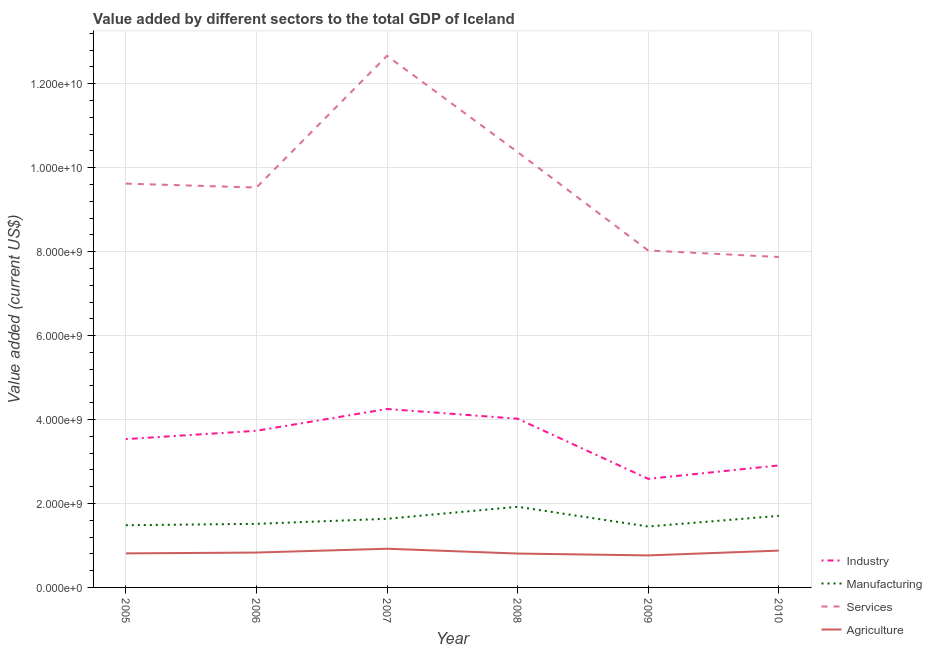How many different coloured lines are there?
Your response must be concise. 4. Is the number of lines equal to the number of legend labels?
Offer a terse response. Yes. What is the value added by manufacturing sector in 2008?
Offer a terse response. 1.92e+09. Across all years, what is the maximum value added by services sector?
Your answer should be compact. 1.27e+1. Across all years, what is the minimum value added by services sector?
Provide a short and direct response. 7.87e+09. What is the total value added by industrial sector in the graph?
Give a very brief answer. 2.10e+1. What is the difference between the value added by industrial sector in 2005 and that in 2006?
Make the answer very short. -1.99e+08. What is the difference between the value added by industrial sector in 2006 and the value added by agricultural sector in 2010?
Provide a succinct answer. 2.85e+09. What is the average value added by agricultural sector per year?
Keep it short and to the point. 8.35e+08. In the year 2006, what is the difference between the value added by manufacturing sector and value added by agricultural sector?
Your answer should be very brief. 6.84e+08. In how many years, is the value added by agricultural sector greater than 11200000000 US$?
Your answer should be compact. 0. What is the ratio of the value added by services sector in 2008 to that in 2010?
Your answer should be compact. 1.32. What is the difference between the highest and the second highest value added by agricultural sector?
Keep it short and to the point. 4.46e+07. What is the difference between the highest and the lowest value added by manufacturing sector?
Your answer should be very brief. 4.70e+08. Does the value added by services sector monotonically increase over the years?
Offer a terse response. No. Is the value added by manufacturing sector strictly less than the value added by industrial sector over the years?
Offer a terse response. Yes. How many lines are there?
Ensure brevity in your answer.  4. How many years are there in the graph?
Ensure brevity in your answer.  6. What is the difference between two consecutive major ticks on the Y-axis?
Provide a short and direct response. 2.00e+09. How many legend labels are there?
Offer a terse response. 4. What is the title of the graph?
Provide a succinct answer. Value added by different sectors to the total GDP of Iceland. What is the label or title of the X-axis?
Provide a short and direct response. Year. What is the label or title of the Y-axis?
Your answer should be compact. Value added (current US$). What is the Value added (current US$) in Industry in 2005?
Provide a short and direct response. 3.53e+09. What is the Value added (current US$) of Manufacturing in 2005?
Your answer should be very brief. 1.48e+09. What is the Value added (current US$) in Services in 2005?
Your response must be concise. 9.62e+09. What is the Value added (current US$) of Agriculture in 2005?
Your answer should be compact. 8.11e+08. What is the Value added (current US$) of Industry in 2006?
Provide a short and direct response. 3.73e+09. What is the Value added (current US$) in Manufacturing in 2006?
Offer a terse response. 1.51e+09. What is the Value added (current US$) in Services in 2006?
Keep it short and to the point. 9.53e+09. What is the Value added (current US$) in Agriculture in 2006?
Your answer should be compact. 8.31e+08. What is the Value added (current US$) in Industry in 2007?
Ensure brevity in your answer.  4.25e+09. What is the Value added (current US$) of Manufacturing in 2007?
Make the answer very short. 1.64e+09. What is the Value added (current US$) in Services in 2007?
Keep it short and to the point. 1.27e+1. What is the Value added (current US$) of Agriculture in 2007?
Give a very brief answer. 9.22e+08. What is the Value added (current US$) in Industry in 2008?
Give a very brief answer. 4.02e+09. What is the Value added (current US$) in Manufacturing in 2008?
Offer a very short reply. 1.92e+09. What is the Value added (current US$) of Services in 2008?
Give a very brief answer. 1.04e+1. What is the Value added (current US$) of Agriculture in 2008?
Offer a very short reply. 8.07e+08. What is the Value added (current US$) of Industry in 2009?
Your answer should be compact. 2.59e+09. What is the Value added (current US$) in Manufacturing in 2009?
Provide a succinct answer. 1.45e+09. What is the Value added (current US$) in Services in 2009?
Ensure brevity in your answer.  8.03e+09. What is the Value added (current US$) of Agriculture in 2009?
Your answer should be compact. 7.63e+08. What is the Value added (current US$) in Industry in 2010?
Your answer should be compact. 2.91e+09. What is the Value added (current US$) in Manufacturing in 2010?
Provide a succinct answer. 1.71e+09. What is the Value added (current US$) in Services in 2010?
Provide a succinct answer. 7.87e+09. What is the Value added (current US$) of Agriculture in 2010?
Give a very brief answer. 8.77e+08. Across all years, what is the maximum Value added (current US$) in Industry?
Provide a short and direct response. 4.25e+09. Across all years, what is the maximum Value added (current US$) of Manufacturing?
Give a very brief answer. 1.92e+09. Across all years, what is the maximum Value added (current US$) of Services?
Make the answer very short. 1.27e+1. Across all years, what is the maximum Value added (current US$) in Agriculture?
Your answer should be very brief. 9.22e+08. Across all years, what is the minimum Value added (current US$) of Industry?
Provide a short and direct response. 2.59e+09. Across all years, what is the minimum Value added (current US$) of Manufacturing?
Your answer should be very brief. 1.45e+09. Across all years, what is the minimum Value added (current US$) of Services?
Provide a succinct answer. 7.87e+09. Across all years, what is the minimum Value added (current US$) in Agriculture?
Ensure brevity in your answer.  7.63e+08. What is the total Value added (current US$) in Industry in the graph?
Give a very brief answer. 2.10e+1. What is the total Value added (current US$) of Manufacturing in the graph?
Offer a very short reply. 9.71e+09. What is the total Value added (current US$) of Services in the graph?
Give a very brief answer. 5.81e+1. What is the total Value added (current US$) of Agriculture in the graph?
Offer a terse response. 5.01e+09. What is the difference between the Value added (current US$) in Industry in 2005 and that in 2006?
Your answer should be compact. -1.99e+08. What is the difference between the Value added (current US$) of Manufacturing in 2005 and that in 2006?
Offer a terse response. -3.30e+07. What is the difference between the Value added (current US$) in Services in 2005 and that in 2006?
Provide a succinct answer. 9.41e+07. What is the difference between the Value added (current US$) of Agriculture in 2005 and that in 2006?
Your response must be concise. -1.96e+07. What is the difference between the Value added (current US$) in Industry in 2005 and that in 2007?
Your answer should be very brief. -7.18e+08. What is the difference between the Value added (current US$) in Manufacturing in 2005 and that in 2007?
Offer a terse response. -1.54e+08. What is the difference between the Value added (current US$) in Services in 2005 and that in 2007?
Your answer should be compact. -3.04e+09. What is the difference between the Value added (current US$) in Agriculture in 2005 and that in 2007?
Offer a terse response. -1.11e+08. What is the difference between the Value added (current US$) in Industry in 2005 and that in 2008?
Provide a succinct answer. -4.86e+08. What is the difference between the Value added (current US$) in Manufacturing in 2005 and that in 2008?
Offer a very short reply. -4.40e+08. What is the difference between the Value added (current US$) of Services in 2005 and that in 2008?
Offer a very short reply. -7.51e+08. What is the difference between the Value added (current US$) of Agriculture in 2005 and that in 2008?
Provide a succinct answer. 4.00e+06. What is the difference between the Value added (current US$) of Industry in 2005 and that in 2009?
Provide a succinct answer. 9.47e+08. What is the difference between the Value added (current US$) of Manufacturing in 2005 and that in 2009?
Your answer should be compact. 3.03e+07. What is the difference between the Value added (current US$) in Services in 2005 and that in 2009?
Offer a terse response. 1.59e+09. What is the difference between the Value added (current US$) of Agriculture in 2005 and that in 2009?
Keep it short and to the point. 4.81e+07. What is the difference between the Value added (current US$) in Industry in 2005 and that in 2010?
Provide a succinct answer. 6.27e+08. What is the difference between the Value added (current US$) of Manufacturing in 2005 and that in 2010?
Offer a terse response. -2.24e+08. What is the difference between the Value added (current US$) in Services in 2005 and that in 2010?
Offer a terse response. 1.75e+09. What is the difference between the Value added (current US$) of Agriculture in 2005 and that in 2010?
Make the answer very short. -6.60e+07. What is the difference between the Value added (current US$) of Industry in 2006 and that in 2007?
Provide a short and direct response. -5.20e+08. What is the difference between the Value added (current US$) of Manufacturing in 2006 and that in 2007?
Your answer should be very brief. -1.21e+08. What is the difference between the Value added (current US$) in Services in 2006 and that in 2007?
Your response must be concise. -3.14e+09. What is the difference between the Value added (current US$) of Agriculture in 2006 and that in 2007?
Offer a very short reply. -9.09e+07. What is the difference between the Value added (current US$) in Industry in 2006 and that in 2008?
Make the answer very short. -2.88e+08. What is the difference between the Value added (current US$) of Manufacturing in 2006 and that in 2008?
Ensure brevity in your answer.  -4.07e+08. What is the difference between the Value added (current US$) in Services in 2006 and that in 2008?
Your answer should be very brief. -8.45e+08. What is the difference between the Value added (current US$) of Agriculture in 2006 and that in 2008?
Ensure brevity in your answer.  2.36e+07. What is the difference between the Value added (current US$) in Industry in 2006 and that in 2009?
Keep it short and to the point. 1.15e+09. What is the difference between the Value added (current US$) of Manufacturing in 2006 and that in 2009?
Give a very brief answer. 6.34e+07. What is the difference between the Value added (current US$) of Services in 2006 and that in 2009?
Your answer should be compact. 1.50e+09. What is the difference between the Value added (current US$) in Agriculture in 2006 and that in 2009?
Provide a succinct answer. 6.78e+07. What is the difference between the Value added (current US$) in Industry in 2006 and that in 2010?
Your response must be concise. 8.25e+08. What is the difference between the Value added (current US$) in Manufacturing in 2006 and that in 2010?
Offer a very short reply. -1.91e+08. What is the difference between the Value added (current US$) of Services in 2006 and that in 2010?
Your response must be concise. 1.65e+09. What is the difference between the Value added (current US$) of Agriculture in 2006 and that in 2010?
Make the answer very short. -4.64e+07. What is the difference between the Value added (current US$) of Industry in 2007 and that in 2008?
Make the answer very short. 2.32e+08. What is the difference between the Value added (current US$) of Manufacturing in 2007 and that in 2008?
Provide a short and direct response. -2.86e+08. What is the difference between the Value added (current US$) in Services in 2007 and that in 2008?
Provide a succinct answer. 2.29e+09. What is the difference between the Value added (current US$) of Agriculture in 2007 and that in 2008?
Provide a short and direct response. 1.15e+08. What is the difference between the Value added (current US$) in Industry in 2007 and that in 2009?
Your response must be concise. 1.66e+09. What is the difference between the Value added (current US$) of Manufacturing in 2007 and that in 2009?
Offer a terse response. 1.84e+08. What is the difference between the Value added (current US$) of Services in 2007 and that in 2009?
Ensure brevity in your answer.  4.64e+09. What is the difference between the Value added (current US$) in Agriculture in 2007 and that in 2009?
Keep it short and to the point. 1.59e+08. What is the difference between the Value added (current US$) in Industry in 2007 and that in 2010?
Ensure brevity in your answer.  1.35e+09. What is the difference between the Value added (current US$) of Manufacturing in 2007 and that in 2010?
Your answer should be compact. -7.01e+07. What is the difference between the Value added (current US$) in Services in 2007 and that in 2010?
Your answer should be compact. 4.79e+09. What is the difference between the Value added (current US$) of Agriculture in 2007 and that in 2010?
Ensure brevity in your answer.  4.46e+07. What is the difference between the Value added (current US$) of Industry in 2008 and that in 2009?
Ensure brevity in your answer.  1.43e+09. What is the difference between the Value added (current US$) in Manufacturing in 2008 and that in 2009?
Keep it short and to the point. 4.70e+08. What is the difference between the Value added (current US$) in Services in 2008 and that in 2009?
Give a very brief answer. 2.34e+09. What is the difference between the Value added (current US$) in Agriculture in 2008 and that in 2009?
Provide a short and direct response. 4.41e+07. What is the difference between the Value added (current US$) of Industry in 2008 and that in 2010?
Ensure brevity in your answer.  1.11e+09. What is the difference between the Value added (current US$) of Manufacturing in 2008 and that in 2010?
Provide a succinct answer. 2.16e+08. What is the difference between the Value added (current US$) of Services in 2008 and that in 2010?
Give a very brief answer. 2.50e+09. What is the difference between the Value added (current US$) in Agriculture in 2008 and that in 2010?
Offer a terse response. -7.00e+07. What is the difference between the Value added (current US$) in Industry in 2009 and that in 2010?
Provide a short and direct response. -3.20e+08. What is the difference between the Value added (current US$) in Manufacturing in 2009 and that in 2010?
Provide a short and direct response. -2.54e+08. What is the difference between the Value added (current US$) in Services in 2009 and that in 2010?
Your answer should be very brief. 1.55e+08. What is the difference between the Value added (current US$) in Agriculture in 2009 and that in 2010?
Make the answer very short. -1.14e+08. What is the difference between the Value added (current US$) of Industry in 2005 and the Value added (current US$) of Manufacturing in 2006?
Offer a very short reply. 2.02e+09. What is the difference between the Value added (current US$) in Industry in 2005 and the Value added (current US$) in Services in 2006?
Your response must be concise. -5.99e+09. What is the difference between the Value added (current US$) of Industry in 2005 and the Value added (current US$) of Agriculture in 2006?
Provide a succinct answer. 2.70e+09. What is the difference between the Value added (current US$) of Manufacturing in 2005 and the Value added (current US$) of Services in 2006?
Offer a terse response. -8.05e+09. What is the difference between the Value added (current US$) of Manufacturing in 2005 and the Value added (current US$) of Agriculture in 2006?
Offer a very short reply. 6.51e+08. What is the difference between the Value added (current US$) of Services in 2005 and the Value added (current US$) of Agriculture in 2006?
Your answer should be compact. 8.79e+09. What is the difference between the Value added (current US$) of Industry in 2005 and the Value added (current US$) of Manufacturing in 2007?
Your response must be concise. 1.90e+09. What is the difference between the Value added (current US$) in Industry in 2005 and the Value added (current US$) in Services in 2007?
Keep it short and to the point. -9.13e+09. What is the difference between the Value added (current US$) of Industry in 2005 and the Value added (current US$) of Agriculture in 2007?
Provide a short and direct response. 2.61e+09. What is the difference between the Value added (current US$) of Manufacturing in 2005 and the Value added (current US$) of Services in 2007?
Offer a very short reply. -1.12e+1. What is the difference between the Value added (current US$) in Manufacturing in 2005 and the Value added (current US$) in Agriculture in 2007?
Ensure brevity in your answer.  5.60e+08. What is the difference between the Value added (current US$) of Services in 2005 and the Value added (current US$) of Agriculture in 2007?
Your answer should be compact. 8.70e+09. What is the difference between the Value added (current US$) in Industry in 2005 and the Value added (current US$) in Manufacturing in 2008?
Provide a succinct answer. 1.61e+09. What is the difference between the Value added (current US$) in Industry in 2005 and the Value added (current US$) in Services in 2008?
Offer a very short reply. -6.84e+09. What is the difference between the Value added (current US$) in Industry in 2005 and the Value added (current US$) in Agriculture in 2008?
Make the answer very short. 2.73e+09. What is the difference between the Value added (current US$) in Manufacturing in 2005 and the Value added (current US$) in Services in 2008?
Provide a succinct answer. -8.89e+09. What is the difference between the Value added (current US$) in Manufacturing in 2005 and the Value added (current US$) in Agriculture in 2008?
Offer a terse response. 6.75e+08. What is the difference between the Value added (current US$) in Services in 2005 and the Value added (current US$) in Agriculture in 2008?
Offer a terse response. 8.81e+09. What is the difference between the Value added (current US$) of Industry in 2005 and the Value added (current US$) of Manufacturing in 2009?
Provide a succinct answer. 2.08e+09. What is the difference between the Value added (current US$) of Industry in 2005 and the Value added (current US$) of Services in 2009?
Ensure brevity in your answer.  -4.49e+09. What is the difference between the Value added (current US$) of Industry in 2005 and the Value added (current US$) of Agriculture in 2009?
Your answer should be very brief. 2.77e+09. What is the difference between the Value added (current US$) of Manufacturing in 2005 and the Value added (current US$) of Services in 2009?
Ensure brevity in your answer.  -6.55e+09. What is the difference between the Value added (current US$) in Manufacturing in 2005 and the Value added (current US$) in Agriculture in 2009?
Provide a succinct answer. 7.19e+08. What is the difference between the Value added (current US$) in Services in 2005 and the Value added (current US$) in Agriculture in 2009?
Offer a very short reply. 8.86e+09. What is the difference between the Value added (current US$) of Industry in 2005 and the Value added (current US$) of Manufacturing in 2010?
Provide a short and direct response. 1.83e+09. What is the difference between the Value added (current US$) in Industry in 2005 and the Value added (current US$) in Services in 2010?
Offer a terse response. -4.34e+09. What is the difference between the Value added (current US$) of Industry in 2005 and the Value added (current US$) of Agriculture in 2010?
Keep it short and to the point. 2.66e+09. What is the difference between the Value added (current US$) of Manufacturing in 2005 and the Value added (current US$) of Services in 2010?
Provide a short and direct response. -6.39e+09. What is the difference between the Value added (current US$) of Manufacturing in 2005 and the Value added (current US$) of Agriculture in 2010?
Offer a very short reply. 6.04e+08. What is the difference between the Value added (current US$) of Services in 2005 and the Value added (current US$) of Agriculture in 2010?
Offer a terse response. 8.74e+09. What is the difference between the Value added (current US$) of Industry in 2006 and the Value added (current US$) of Manufacturing in 2007?
Offer a terse response. 2.10e+09. What is the difference between the Value added (current US$) of Industry in 2006 and the Value added (current US$) of Services in 2007?
Provide a succinct answer. -8.93e+09. What is the difference between the Value added (current US$) of Industry in 2006 and the Value added (current US$) of Agriculture in 2007?
Your response must be concise. 2.81e+09. What is the difference between the Value added (current US$) in Manufacturing in 2006 and the Value added (current US$) in Services in 2007?
Offer a very short reply. -1.12e+1. What is the difference between the Value added (current US$) in Manufacturing in 2006 and the Value added (current US$) in Agriculture in 2007?
Offer a terse response. 5.93e+08. What is the difference between the Value added (current US$) in Services in 2006 and the Value added (current US$) in Agriculture in 2007?
Provide a succinct answer. 8.61e+09. What is the difference between the Value added (current US$) of Industry in 2006 and the Value added (current US$) of Manufacturing in 2008?
Provide a succinct answer. 1.81e+09. What is the difference between the Value added (current US$) in Industry in 2006 and the Value added (current US$) in Services in 2008?
Offer a very short reply. -6.64e+09. What is the difference between the Value added (current US$) in Industry in 2006 and the Value added (current US$) in Agriculture in 2008?
Keep it short and to the point. 2.92e+09. What is the difference between the Value added (current US$) of Manufacturing in 2006 and the Value added (current US$) of Services in 2008?
Ensure brevity in your answer.  -8.86e+09. What is the difference between the Value added (current US$) in Manufacturing in 2006 and the Value added (current US$) in Agriculture in 2008?
Ensure brevity in your answer.  7.08e+08. What is the difference between the Value added (current US$) in Services in 2006 and the Value added (current US$) in Agriculture in 2008?
Ensure brevity in your answer.  8.72e+09. What is the difference between the Value added (current US$) of Industry in 2006 and the Value added (current US$) of Manufacturing in 2009?
Offer a very short reply. 2.28e+09. What is the difference between the Value added (current US$) of Industry in 2006 and the Value added (current US$) of Services in 2009?
Offer a very short reply. -4.30e+09. What is the difference between the Value added (current US$) of Industry in 2006 and the Value added (current US$) of Agriculture in 2009?
Make the answer very short. 2.97e+09. What is the difference between the Value added (current US$) of Manufacturing in 2006 and the Value added (current US$) of Services in 2009?
Offer a terse response. -6.51e+09. What is the difference between the Value added (current US$) in Manufacturing in 2006 and the Value added (current US$) in Agriculture in 2009?
Ensure brevity in your answer.  7.52e+08. What is the difference between the Value added (current US$) in Services in 2006 and the Value added (current US$) in Agriculture in 2009?
Your answer should be very brief. 8.76e+09. What is the difference between the Value added (current US$) in Industry in 2006 and the Value added (current US$) in Manufacturing in 2010?
Your answer should be compact. 2.03e+09. What is the difference between the Value added (current US$) of Industry in 2006 and the Value added (current US$) of Services in 2010?
Provide a short and direct response. -4.14e+09. What is the difference between the Value added (current US$) in Industry in 2006 and the Value added (current US$) in Agriculture in 2010?
Offer a terse response. 2.85e+09. What is the difference between the Value added (current US$) in Manufacturing in 2006 and the Value added (current US$) in Services in 2010?
Give a very brief answer. -6.36e+09. What is the difference between the Value added (current US$) in Manufacturing in 2006 and the Value added (current US$) in Agriculture in 2010?
Make the answer very short. 6.38e+08. What is the difference between the Value added (current US$) in Services in 2006 and the Value added (current US$) in Agriculture in 2010?
Offer a terse response. 8.65e+09. What is the difference between the Value added (current US$) in Industry in 2007 and the Value added (current US$) in Manufacturing in 2008?
Keep it short and to the point. 2.33e+09. What is the difference between the Value added (current US$) in Industry in 2007 and the Value added (current US$) in Services in 2008?
Offer a terse response. -6.12e+09. What is the difference between the Value added (current US$) in Industry in 2007 and the Value added (current US$) in Agriculture in 2008?
Your response must be concise. 3.44e+09. What is the difference between the Value added (current US$) of Manufacturing in 2007 and the Value added (current US$) of Services in 2008?
Provide a short and direct response. -8.74e+09. What is the difference between the Value added (current US$) of Manufacturing in 2007 and the Value added (current US$) of Agriculture in 2008?
Your response must be concise. 8.28e+08. What is the difference between the Value added (current US$) in Services in 2007 and the Value added (current US$) in Agriculture in 2008?
Provide a short and direct response. 1.19e+1. What is the difference between the Value added (current US$) in Industry in 2007 and the Value added (current US$) in Manufacturing in 2009?
Give a very brief answer. 2.80e+09. What is the difference between the Value added (current US$) in Industry in 2007 and the Value added (current US$) in Services in 2009?
Ensure brevity in your answer.  -3.78e+09. What is the difference between the Value added (current US$) in Industry in 2007 and the Value added (current US$) in Agriculture in 2009?
Your answer should be very brief. 3.49e+09. What is the difference between the Value added (current US$) in Manufacturing in 2007 and the Value added (current US$) in Services in 2009?
Your answer should be very brief. -6.39e+09. What is the difference between the Value added (current US$) of Manufacturing in 2007 and the Value added (current US$) of Agriculture in 2009?
Make the answer very short. 8.72e+08. What is the difference between the Value added (current US$) of Services in 2007 and the Value added (current US$) of Agriculture in 2009?
Offer a very short reply. 1.19e+1. What is the difference between the Value added (current US$) in Industry in 2007 and the Value added (current US$) in Manufacturing in 2010?
Your answer should be compact. 2.55e+09. What is the difference between the Value added (current US$) in Industry in 2007 and the Value added (current US$) in Services in 2010?
Ensure brevity in your answer.  -3.62e+09. What is the difference between the Value added (current US$) of Industry in 2007 and the Value added (current US$) of Agriculture in 2010?
Give a very brief answer. 3.37e+09. What is the difference between the Value added (current US$) of Manufacturing in 2007 and the Value added (current US$) of Services in 2010?
Keep it short and to the point. -6.24e+09. What is the difference between the Value added (current US$) in Manufacturing in 2007 and the Value added (current US$) in Agriculture in 2010?
Your answer should be compact. 7.58e+08. What is the difference between the Value added (current US$) in Services in 2007 and the Value added (current US$) in Agriculture in 2010?
Provide a succinct answer. 1.18e+1. What is the difference between the Value added (current US$) of Industry in 2008 and the Value added (current US$) of Manufacturing in 2009?
Your answer should be compact. 2.57e+09. What is the difference between the Value added (current US$) in Industry in 2008 and the Value added (current US$) in Services in 2009?
Give a very brief answer. -4.01e+09. What is the difference between the Value added (current US$) in Industry in 2008 and the Value added (current US$) in Agriculture in 2009?
Offer a terse response. 3.26e+09. What is the difference between the Value added (current US$) in Manufacturing in 2008 and the Value added (current US$) in Services in 2009?
Offer a very short reply. -6.11e+09. What is the difference between the Value added (current US$) in Manufacturing in 2008 and the Value added (current US$) in Agriculture in 2009?
Give a very brief answer. 1.16e+09. What is the difference between the Value added (current US$) in Services in 2008 and the Value added (current US$) in Agriculture in 2009?
Make the answer very short. 9.61e+09. What is the difference between the Value added (current US$) in Industry in 2008 and the Value added (current US$) in Manufacturing in 2010?
Give a very brief answer. 2.31e+09. What is the difference between the Value added (current US$) in Industry in 2008 and the Value added (current US$) in Services in 2010?
Give a very brief answer. -3.85e+09. What is the difference between the Value added (current US$) in Industry in 2008 and the Value added (current US$) in Agriculture in 2010?
Offer a terse response. 3.14e+09. What is the difference between the Value added (current US$) in Manufacturing in 2008 and the Value added (current US$) in Services in 2010?
Keep it short and to the point. -5.95e+09. What is the difference between the Value added (current US$) in Manufacturing in 2008 and the Value added (current US$) in Agriculture in 2010?
Your response must be concise. 1.04e+09. What is the difference between the Value added (current US$) in Services in 2008 and the Value added (current US$) in Agriculture in 2010?
Provide a succinct answer. 9.49e+09. What is the difference between the Value added (current US$) in Industry in 2009 and the Value added (current US$) in Manufacturing in 2010?
Offer a terse response. 8.81e+08. What is the difference between the Value added (current US$) in Industry in 2009 and the Value added (current US$) in Services in 2010?
Ensure brevity in your answer.  -5.29e+09. What is the difference between the Value added (current US$) in Industry in 2009 and the Value added (current US$) in Agriculture in 2010?
Provide a succinct answer. 1.71e+09. What is the difference between the Value added (current US$) of Manufacturing in 2009 and the Value added (current US$) of Services in 2010?
Ensure brevity in your answer.  -6.42e+09. What is the difference between the Value added (current US$) of Manufacturing in 2009 and the Value added (current US$) of Agriculture in 2010?
Your response must be concise. 5.74e+08. What is the difference between the Value added (current US$) of Services in 2009 and the Value added (current US$) of Agriculture in 2010?
Your response must be concise. 7.15e+09. What is the average Value added (current US$) of Industry per year?
Provide a succinct answer. 3.50e+09. What is the average Value added (current US$) in Manufacturing per year?
Your answer should be compact. 1.62e+09. What is the average Value added (current US$) in Services per year?
Your response must be concise. 9.68e+09. What is the average Value added (current US$) in Agriculture per year?
Your answer should be compact. 8.35e+08. In the year 2005, what is the difference between the Value added (current US$) in Industry and Value added (current US$) in Manufacturing?
Your response must be concise. 2.05e+09. In the year 2005, what is the difference between the Value added (current US$) of Industry and Value added (current US$) of Services?
Ensure brevity in your answer.  -6.09e+09. In the year 2005, what is the difference between the Value added (current US$) of Industry and Value added (current US$) of Agriculture?
Ensure brevity in your answer.  2.72e+09. In the year 2005, what is the difference between the Value added (current US$) in Manufacturing and Value added (current US$) in Services?
Give a very brief answer. -8.14e+09. In the year 2005, what is the difference between the Value added (current US$) in Manufacturing and Value added (current US$) in Agriculture?
Offer a terse response. 6.71e+08. In the year 2005, what is the difference between the Value added (current US$) of Services and Value added (current US$) of Agriculture?
Make the answer very short. 8.81e+09. In the year 2006, what is the difference between the Value added (current US$) of Industry and Value added (current US$) of Manufacturing?
Offer a very short reply. 2.22e+09. In the year 2006, what is the difference between the Value added (current US$) of Industry and Value added (current US$) of Services?
Provide a short and direct response. -5.80e+09. In the year 2006, what is the difference between the Value added (current US$) of Industry and Value added (current US$) of Agriculture?
Make the answer very short. 2.90e+09. In the year 2006, what is the difference between the Value added (current US$) of Manufacturing and Value added (current US$) of Services?
Your answer should be compact. -8.01e+09. In the year 2006, what is the difference between the Value added (current US$) in Manufacturing and Value added (current US$) in Agriculture?
Keep it short and to the point. 6.84e+08. In the year 2006, what is the difference between the Value added (current US$) of Services and Value added (current US$) of Agriculture?
Your answer should be compact. 8.70e+09. In the year 2007, what is the difference between the Value added (current US$) in Industry and Value added (current US$) in Manufacturing?
Ensure brevity in your answer.  2.62e+09. In the year 2007, what is the difference between the Value added (current US$) of Industry and Value added (current US$) of Services?
Your response must be concise. -8.41e+09. In the year 2007, what is the difference between the Value added (current US$) of Industry and Value added (current US$) of Agriculture?
Ensure brevity in your answer.  3.33e+09. In the year 2007, what is the difference between the Value added (current US$) of Manufacturing and Value added (current US$) of Services?
Provide a short and direct response. -1.10e+1. In the year 2007, what is the difference between the Value added (current US$) in Manufacturing and Value added (current US$) in Agriculture?
Make the answer very short. 7.14e+08. In the year 2007, what is the difference between the Value added (current US$) of Services and Value added (current US$) of Agriculture?
Offer a very short reply. 1.17e+1. In the year 2008, what is the difference between the Value added (current US$) of Industry and Value added (current US$) of Manufacturing?
Offer a very short reply. 2.10e+09. In the year 2008, what is the difference between the Value added (current US$) in Industry and Value added (current US$) in Services?
Your answer should be very brief. -6.35e+09. In the year 2008, what is the difference between the Value added (current US$) in Industry and Value added (current US$) in Agriculture?
Make the answer very short. 3.21e+09. In the year 2008, what is the difference between the Value added (current US$) of Manufacturing and Value added (current US$) of Services?
Provide a short and direct response. -8.45e+09. In the year 2008, what is the difference between the Value added (current US$) of Manufacturing and Value added (current US$) of Agriculture?
Keep it short and to the point. 1.11e+09. In the year 2008, what is the difference between the Value added (current US$) in Services and Value added (current US$) in Agriculture?
Keep it short and to the point. 9.56e+09. In the year 2009, what is the difference between the Value added (current US$) of Industry and Value added (current US$) of Manufacturing?
Your answer should be compact. 1.14e+09. In the year 2009, what is the difference between the Value added (current US$) in Industry and Value added (current US$) in Services?
Offer a very short reply. -5.44e+09. In the year 2009, what is the difference between the Value added (current US$) in Industry and Value added (current US$) in Agriculture?
Your response must be concise. 1.82e+09. In the year 2009, what is the difference between the Value added (current US$) in Manufacturing and Value added (current US$) in Services?
Your response must be concise. -6.58e+09. In the year 2009, what is the difference between the Value added (current US$) in Manufacturing and Value added (current US$) in Agriculture?
Provide a short and direct response. 6.88e+08. In the year 2009, what is the difference between the Value added (current US$) of Services and Value added (current US$) of Agriculture?
Offer a very short reply. 7.26e+09. In the year 2010, what is the difference between the Value added (current US$) in Industry and Value added (current US$) in Manufacturing?
Your answer should be very brief. 1.20e+09. In the year 2010, what is the difference between the Value added (current US$) in Industry and Value added (current US$) in Services?
Offer a terse response. -4.97e+09. In the year 2010, what is the difference between the Value added (current US$) of Industry and Value added (current US$) of Agriculture?
Ensure brevity in your answer.  2.03e+09. In the year 2010, what is the difference between the Value added (current US$) in Manufacturing and Value added (current US$) in Services?
Make the answer very short. -6.17e+09. In the year 2010, what is the difference between the Value added (current US$) of Manufacturing and Value added (current US$) of Agriculture?
Give a very brief answer. 8.28e+08. In the year 2010, what is the difference between the Value added (current US$) of Services and Value added (current US$) of Agriculture?
Make the answer very short. 7.00e+09. What is the ratio of the Value added (current US$) in Industry in 2005 to that in 2006?
Give a very brief answer. 0.95. What is the ratio of the Value added (current US$) in Manufacturing in 2005 to that in 2006?
Ensure brevity in your answer.  0.98. What is the ratio of the Value added (current US$) in Services in 2005 to that in 2006?
Make the answer very short. 1.01. What is the ratio of the Value added (current US$) in Agriculture in 2005 to that in 2006?
Offer a very short reply. 0.98. What is the ratio of the Value added (current US$) of Industry in 2005 to that in 2007?
Your answer should be very brief. 0.83. What is the ratio of the Value added (current US$) of Manufacturing in 2005 to that in 2007?
Ensure brevity in your answer.  0.91. What is the ratio of the Value added (current US$) in Services in 2005 to that in 2007?
Your answer should be very brief. 0.76. What is the ratio of the Value added (current US$) in Agriculture in 2005 to that in 2007?
Offer a terse response. 0.88. What is the ratio of the Value added (current US$) of Industry in 2005 to that in 2008?
Your response must be concise. 0.88. What is the ratio of the Value added (current US$) in Manufacturing in 2005 to that in 2008?
Give a very brief answer. 0.77. What is the ratio of the Value added (current US$) in Services in 2005 to that in 2008?
Provide a succinct answer. 0.93. What is the ratio of the Value added (current US$) of Agriculture in 2005 to that in 2008?
Ensure brevity in your answer.  1. What is the ratio of the Value added (current US$) in Industry in 2005 to that in 2009?
Your response must be concise. 1.37. What is the ratio of the Value added (current US$) in Manufacturing in 2005 to that in 2009?
Your answer should be compact. 1.02. What is the ratio of the Value added (current US$) of Services in 2005 to that in 2009?
Your answer should be very brief. 1.2. What is the ratio of the Value added (current US$) of Agriculture in 2005 to that in 2009?
Offer a very short reply. 1.06. What is the ratio of the Value added (current US$) of Industry in 2005 to that in 2010?
Provide a succinct answer. 1.22. What is the ratio of the Value added (current US$) in Manufacturing in 2005 to that in 2010?
Provide a short and direct response. 0.87. What is the ratio of the Value added (current US$) of Services in 2005 to that in 2010?
Provide a succinct answer. 1.22. What is the ratio of the Value added (current US$) of Agriculture in 2005 to that in 2010?
Provide a short and direct response. 0.92. What is the ratio of the Value added (current US$) in Industry in 2006 to that in 2007?
Give a very brief answer. 0.88. What is the ratio of the Value added (current US$) in Manufacturing in 2006 to that in 2007?
Ensure brevity in your answer.  0.93. What is the ratio of the Value added (current US$) of Services in 2006 to that in 2007?
Make the answer very short. 0.75. What is the ratio of the Value added (current US$) of Agriculture in 2006 to that in 2007?
Keep it short and to the point. 0.9. What is the ratio of the Value added (current US$) of Industry in 2006 to that in 2008?
Give a very brief answer. 0.93. What is the ratio of the Value added (current US$) of Manufacturing in 2006 to that in 2008?
Offer a very short reply. 0.79. What is the ratio of the Value added (current US$) in Services in 2006 to that in 2008?
Your answer should be compact. 0.92. What is the ratio of the Value added (current US$) in Agriculture in 2006 to that in 2008?
Keep it short and to the point. 1.03. What is the ratio of the Value added (current US$) in Industry in 2006 to that in 2009?
Provide a short and direct response. 1.44. What is the ratio of the Value added (current US$) of Manufacturing in 2006 to that in 2009?
Offer a very short reply. 1.04. What is the ratio of the Value added (current US$) of Services in 2006 to that in 2009?
Make the answer very short. 1.19. What is the ratio of the Value added (current US$) of Agriculture in 2006 to that in 2009?
Keep it short and to the point. 1.09. What is the ratio of the Value added (current US$) in Industry in 2006 to that in 2010?
Your response must be concise. 1.28. What is the ratio of the Value added (current US$) of Manufacturing in 2006 to that in 2010?
Make the answer very short. 0.89. What is the ratio of the Value added (current US$) in Services in 2006 to that in 2010?
Give a very brief answer. 1.21. What is the ratio of the Value added (current US$) of Agriculture in 2006 to that in 2010?
Your answer should be very brief. 0.95. What is the ratio of the Value added (current US$) in Industry in 2007 to that in 2008?
Keep it short and to the point. 1.06. What is the ratio of the Value added (current US$) in Manufacturing in 2007 to that in 2008?
Give a very brief answer. 0.85. What is the ratio of the Value added (current US$) in Services in 2007 to that in 2008?
Provide a succinct answer. 1.22. What is the ratio of the Value added (current US$) in Agriculture in 2007 to that in 2008?
Give a very brief answer. 1.14. What is the ratio of the Value added (current US$) in Industry in 2007 to that in 2009?
Your answer should be very brief. 1.64. What is the ratio of the Value added (current US$) of Manufacturing in 2007 to that in 2009?
Provide a succinct answer. 1.13. What is the ratio of the Value added (current US$) in Services in 2007 to that in 2009?
Provide a short and direct response. 1.58. What is the ratio of the Value added (current US$) in Agriculture in 2007 to that in 2009?
Keep it short and to the point. 1.21. What is the ratio of the Value added (current US$) in Industry in 2007 to that in 2010?
Offer a terse response. 1.46. What is the ratio of the Value added (current US$) of Manufacturing in 2007 to that in 2010?
Offer a terse response. 0.96. What is the ratio of the Value added (current US$) of Services in 2007 to that in 2010?
Provide a succinct answer. 1.61. What is the ratio of the Value added (current US$) of Agriculture in 2007 to that in 2010?
Make the answer very short. 1.05. What is the ratio of the Value added (current US$) of Industry in 2008 to that in 2009?
Give a very brief answer. 1.55. What is the ratio of the Value added (current US$) in Manufacturing in 2008 to that in 2009?
Your response must be concise. 1.32. What is the ratio of the Value added (current US$) in Services in 2008 to that in 2009?
Offer a very short reply. 1.29. What is the ratio of the Value added (current US$) of Agriculture in 2008 to that in 2009?
Keep it short and to the point. 1.06. What is the ratio of the Value added (current US$) in Industry in 2008 to that in 2010?
Your answer should be compact. 1.38. What is the ratio of the Value added (current US$) of Manufacturing in 2008 to that in 2010?
Keep it short and to the point. 1.13. What is the ratio of the Value added (current US$) of Services in 2008 to that in 2010?
Your response must be concise. 1.32. What is the ratio of the Value added (current US$) of Agriculture in 2008 to that in 2010?
Offer a very short reply. 0.92. What is the ratio of the Value added (current US$) of Industry in 2009 to that in 2010?
Keep it short and to the point. 0.89. What is the ratio of the Value added (current US$) in Manufacturing in 2009 to that in 2010?
Make the answer very short. 0.85. What is the ratio of the Value added (current US$) in Services in 2009 to that in 2010?
Your answer should be very brief. 1.02. What is the ratio of the Value added (current US$) in Agriculture in 2009 to that in 2010?
Your answer should be very brief. 0.87. What is the difference between the highest and the second highest Value added (current US$) in Industry?
Give a very brief answer. 2.32e+08. What is the difference between the highest and the second highest Value added (current US$) of Manufacturing?
Keep it short and to the point. 2.16e+08. What is the difference between the highest and the second highest Value added (current US$) in Services?
Provide a succinct answer. 2.29e+09. What is the difference between the highest and the second highest Value added (current US$) in Agriculture?
Your answer should be compact. 4.46e+07. What is the difference between the highest and the lowest Value added (current US$) in Industry?
Offer a terse response. 1.66e+09. What is the difference between the highest and the lowest Value added (current US$) of Manufacturing?
Your response must be concise. 4.70e+08. What is the difference between the highest and the lowest Value added (current US$) in Services?
Give a very brief answer. 4.79e+09. What is the difference between the highest and the lowest Value added (current US$) of Agriculture?
Keep it short and to the point. 1.59e+08. 